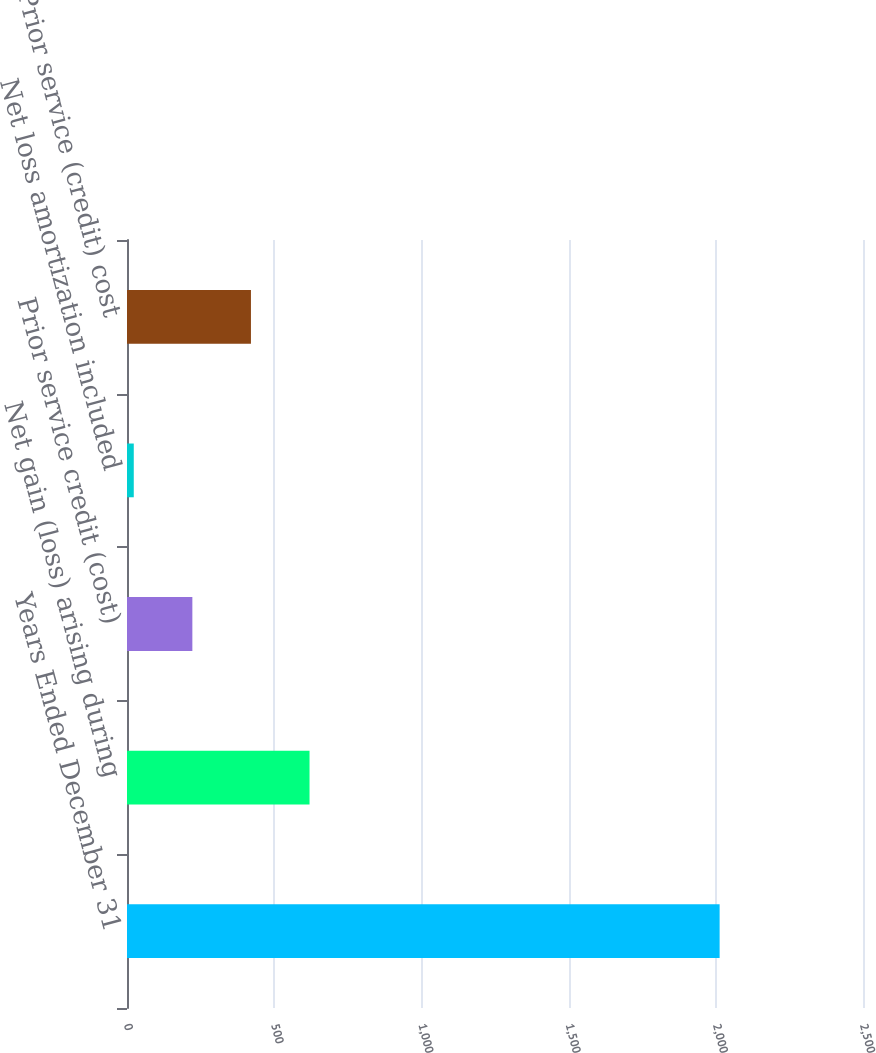Convert chart. <chart><loc_0><loc_0><loc_500><loc_500><bar_chart><fcel>Years Ended December 31<fcel>Net gain (loss) arising during<fcel>Prior service credit (cost)<fcel>Net loss amortization included<fcel>Prior service (credit) cost<nl><fcel>2013<fcel>620<fcel>222<fcel>23<fcel>421<nl></chart> 